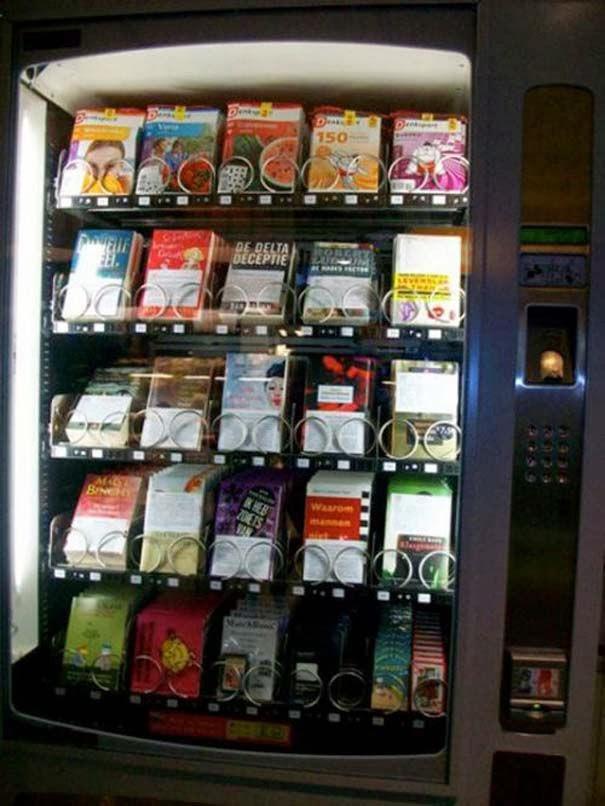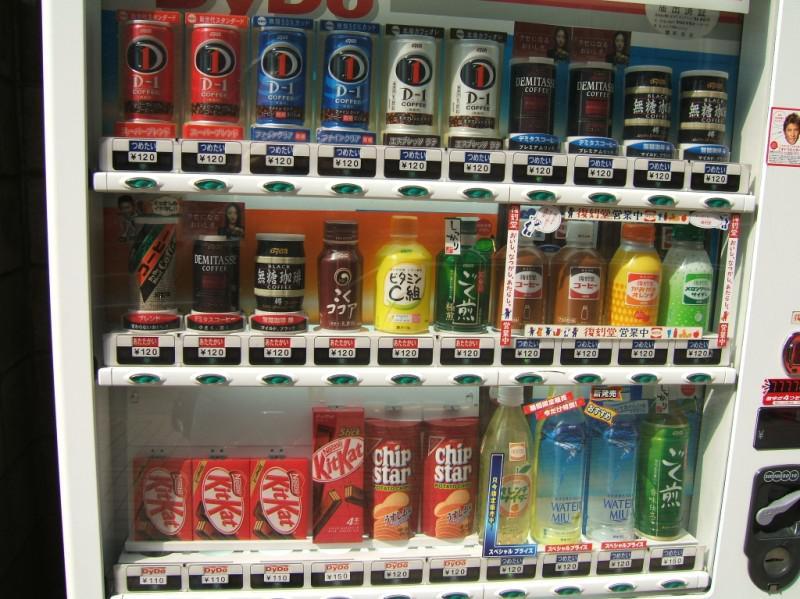The first image is the image on the left, the second image is the image on the right. For the images displayed, is the sentence "Left image shows a vending machine that does not dispense beverages." factually correct? Answer yes or no. Yes. The first image is the image on the left, the second image is the image on the right. Considering the images on both sides, is "there are red vending machines" valid? Answer yes or no. No. 